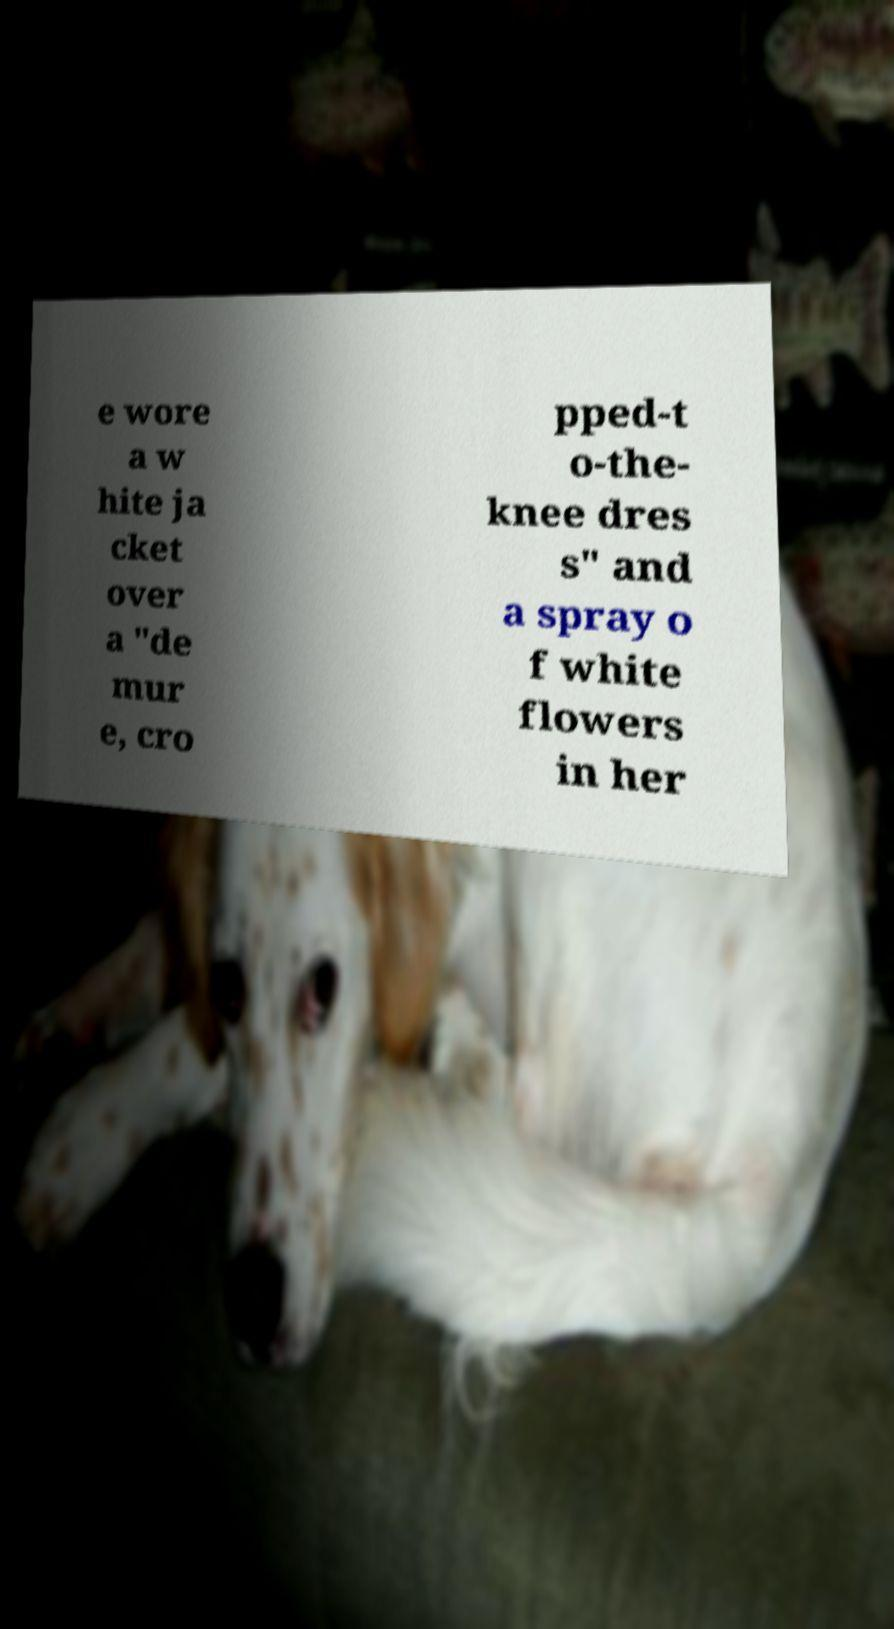Please read and relay the text visible in this image. What does it say? e wore a w hite ja cket over a "de mur e, cro pped-t o-the- knee dres s" and a spray o f white flowers in her 